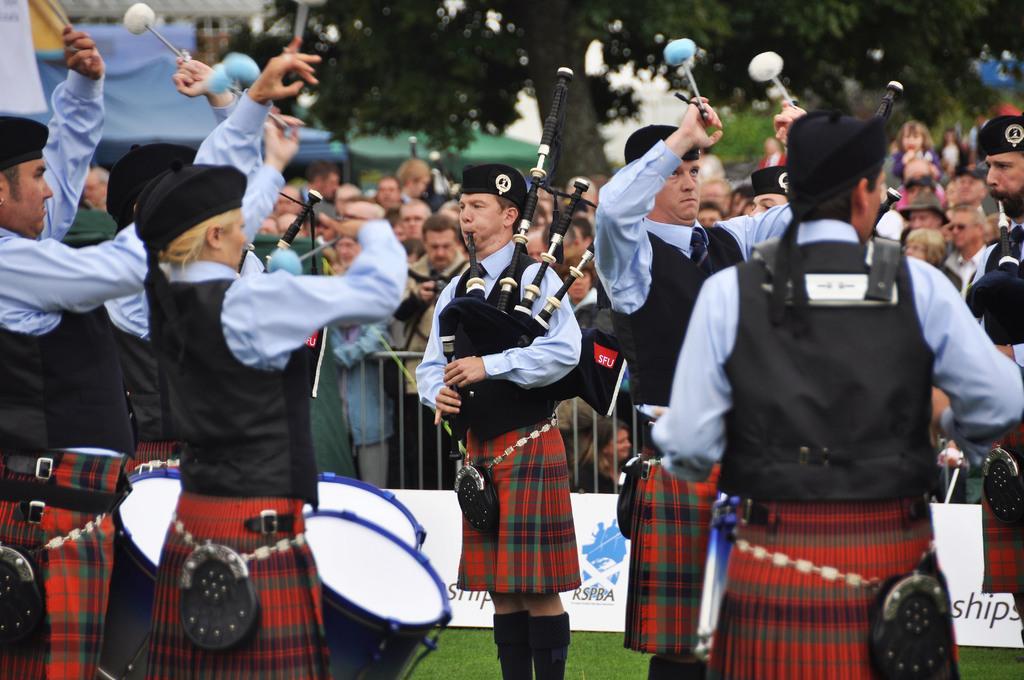In one or two sentences, can you explain what this image depicts? In the foreground of the picture there is a band playing drums. in the center of the picture we can see a person playing bagpipes. In the middle there are people and fencing. In the background we can see trees and buildings. 